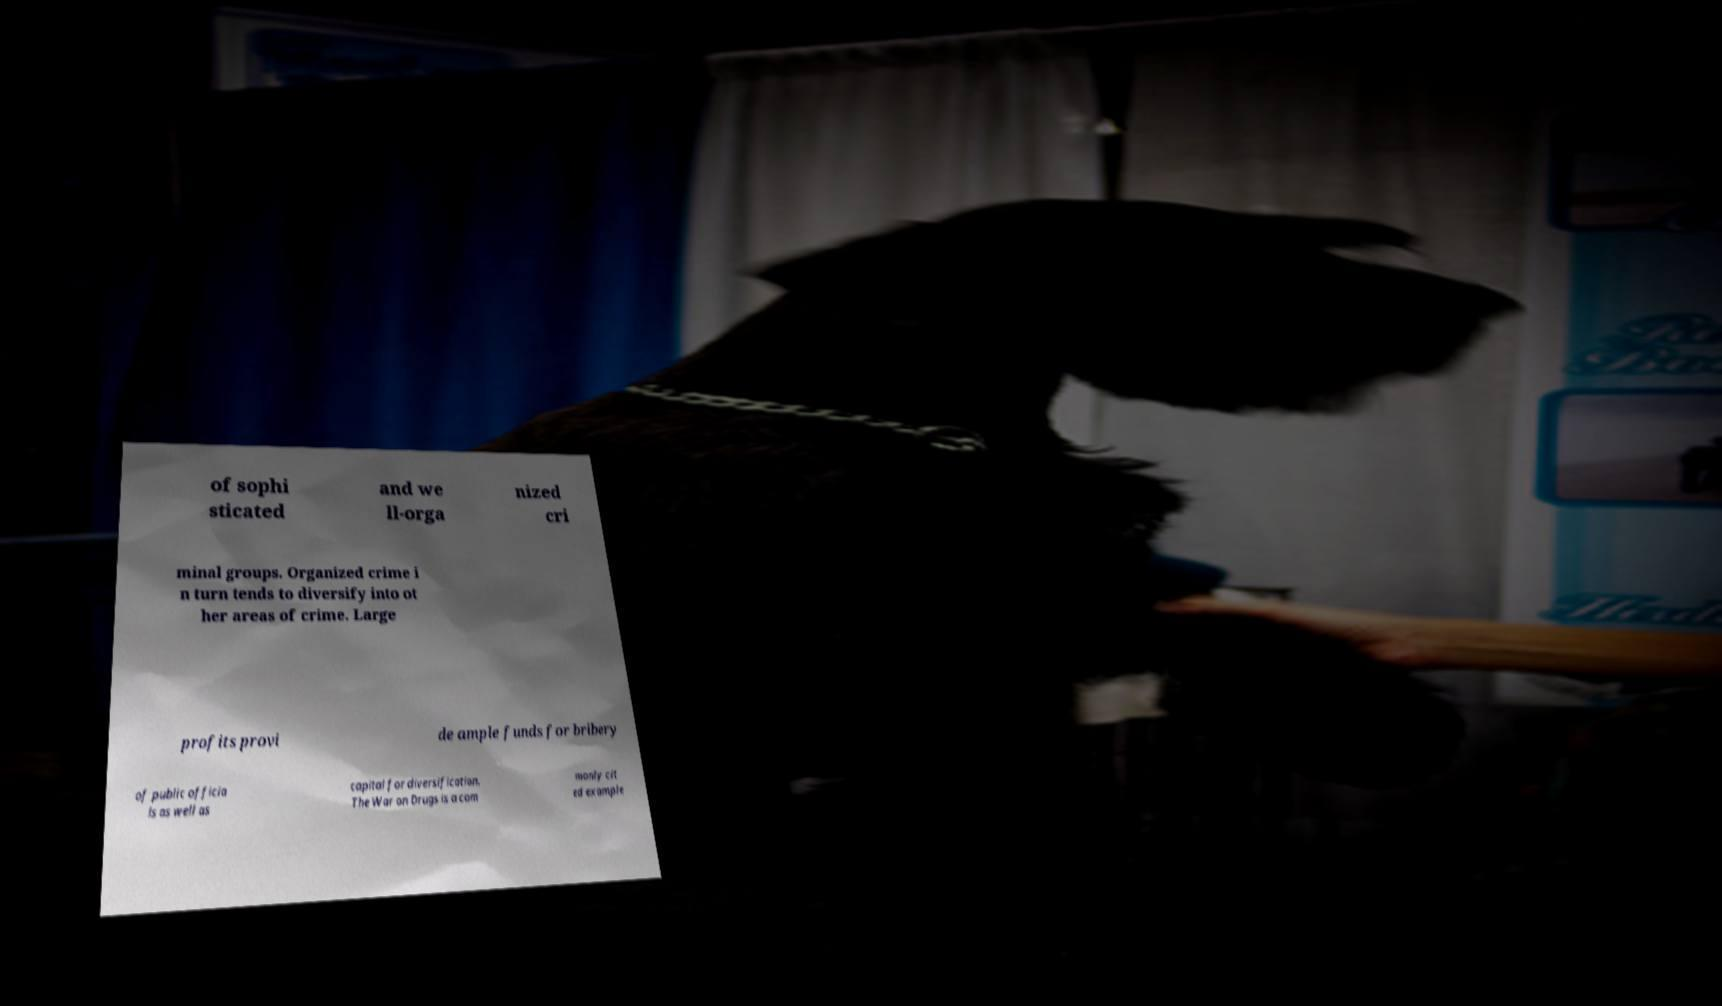For documentation purposes, I need the text within this image transcribed. Could you provide that? of sophi sticated and we ll-orga nized cri minal groups. Organized crime i n turn tends to diversify into ot her areas of crime. Large profits provi de ample funds for bribery of public officia ls as well as capital for diversification. The War on Drugs is a com monly cit ed example 